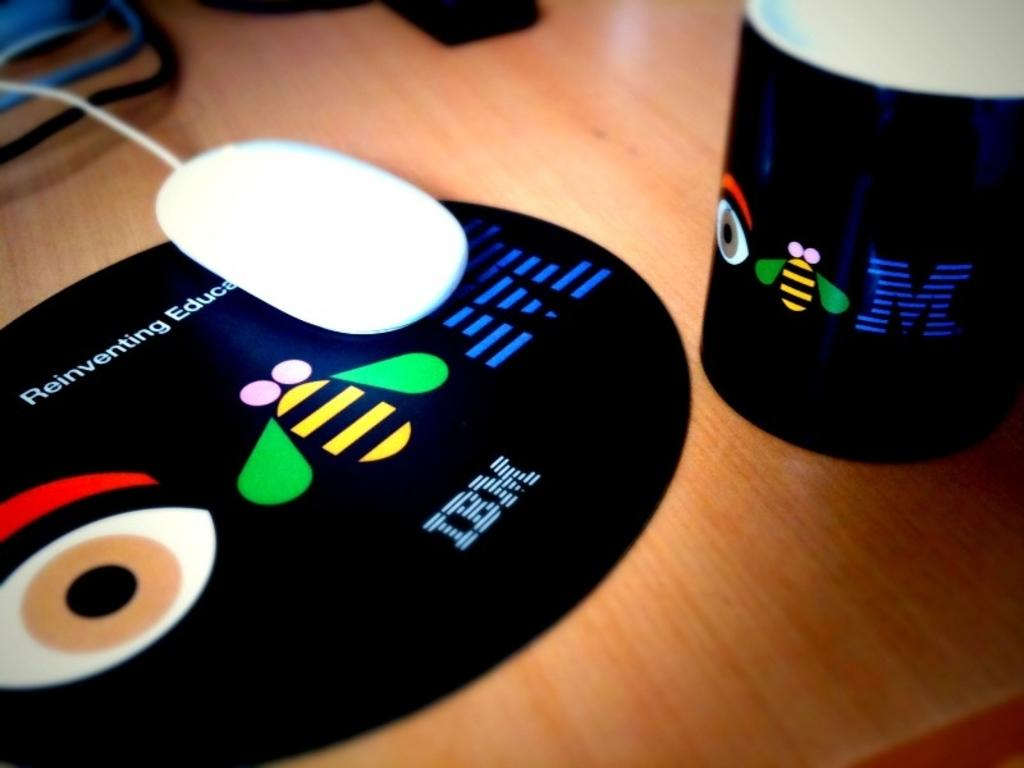<image>
Provide a brief description of the given image. a mouse pad that has the letters IBM on it 